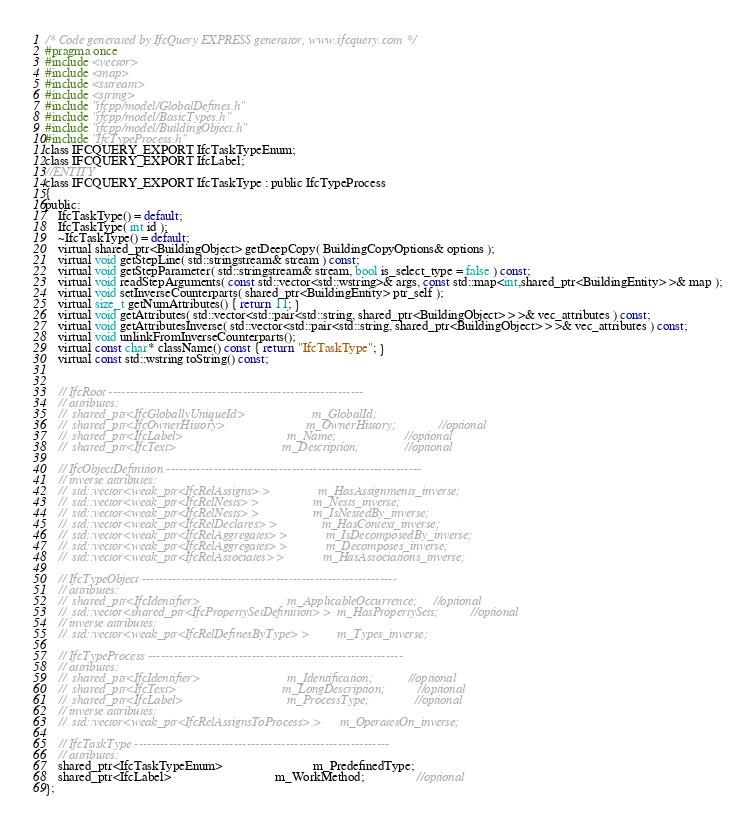<code> <loc_0><loc_0><loc_500><loc_500><_C_>/* Code generated by IfcQuery EXPRESS generator, www.ifcquery.com */
#pragma once
#include <vector>
#include <map>
#include <sstream>
#include <string>
#include "ifcpp/model/GlobalDefines.h"
#include "ifcpp/model/BasicTypes.h"
#include "ifcpp/model/BuildingObject.h"
#include "IfcTypeProcess.h"
class IFCQUERY_EXPORT IfcTaskTypeEnum;
class IFCQUERY_EXPORT IfcLabel;
//ENTITY
class IFCQUERY_EXPORT IfcTaskType : public IfcTypeProcess
{ 
public:
	IfcTaskType() = default;
	IfcTaskType( int id );
	~IfcTaskType() = default;
	virtual shared_ptr<BuildingObject> getDeepCopy( BuildingCopyOptions& options );
	virtual void getStepLine( std::stringstream& stream ) const;
	virtual void getStepParameter( std::stringstream& stream, bool is_select_type = false ) const;
	virtual void readStepArguments( const std::vector<std::wstring>& args, const std::map<int,shared_ptr<BuildingEntity> >& map );
	virtual void setInverseCounterparts( shared_ptr<BuildingEntity> ptr_self );
	virtual size_t getNumAttributes() { return 11; }
	virtual void getAttributes( std::vector<std::pair<std::string, shared_ptr<BuildingObject> > >& vec_attributes ) const;
	virtual void getAttributesInverse( std::vector<std::pair<std::string, shared_ptr<BuildingObject> > >& vec_attributes ) const;
	virtual void unlinkFromInverseCounterparts();
	virtual const char* className() const { return "IfcTaskType"; }
	virtual const std::wstring toString() const;


	// IfcRoot -----------------------------------------------------------
	// attributes:
	//  shared_ptr<IfcGloballyUniqueId>						m_GlobalId;
	//  shared_ptr<IfcOwnerHistory>							m_OwnerHistory;				//optional
	//  shared_ptr<IfcLabel>								m_Name;						//optional
	//  shared_ptr<IfcText>									m_Description;				//optional

	// IfcObjectDefinition -----------------------------------------------------------
	// inverse attributes:
	//  std::vector<weak_ptr<IfcRelAssigns> >				m_HasAssignments_inverse;
	//  std::vector<weak_ptr<IfcRelNests> >					m_Nests_inverse;
	//  std::vector<weak_ptr<IfcRelNests> >					m_IsNestedBy_inverse;
	//  std::vector<weak_ptr<IfcRelDeclares> >				m_HasContext_inverse;
	//  std::vector<weak_ptr<IfcRelAggregates> >			m_IsDecomposedBy_inverse;
	//  std::vector<weak_ptr<IfcRelAggregates> >			m_Decomposes_inverse;
	//  std::vector<weak_ptr<IfcRelAssociates> >			m_HasAssociations_inverse;

	// IfcTypeObject -----------------------------------------------------------
	// attributes:
	//  shared_ptr<IfcIdentifier>							m_ApplicableOccurrence;		//optional
	//  std::vector<shared_ptr<IfcPropertySetDefinition> >	m_HasPropertySets;			//optional
	// inverse attributes:
	//  std::vector<weak_ptr<IfcRelDefinesByType> >			m_Types_inverse;

	// IfcTypeProcess -----------------------------------------------------------
	// attributes:
	//  shared_ptr<IfcIdentifier>							m_Identification;			//optional
	//  shared_ptr<IfcText>									m_LongDescription;			//optional
	//  shared_ptr<IfcLabel>								m_ProcessType;				//optional
	// inverse attributes:
	//  std::vector<weak_ptr<IfcRelAssignsToProcess> >		m_OperatesOn_inverse;

	// IfcTaskType -----------------------------------------------------------
	// attributes:
	shared_ptr<IfcTaskTypeEnum>							m_PredefinedType;
	shared_ptr<IfcLabel>								m_WorkMethod;				//optional
};

</code> 